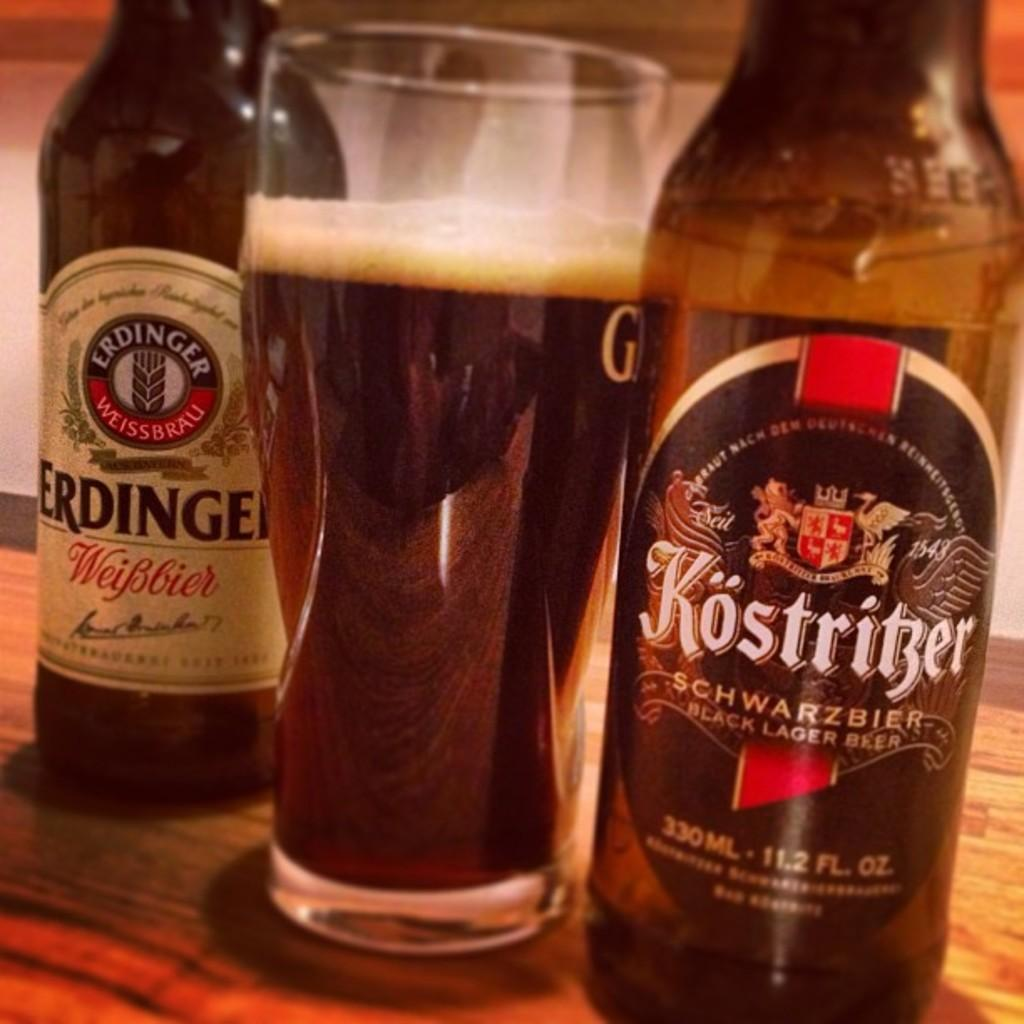<image>
Summarize the visual content of the image. A bottle of Kostritzer lager sits next to a full glass of beer. 